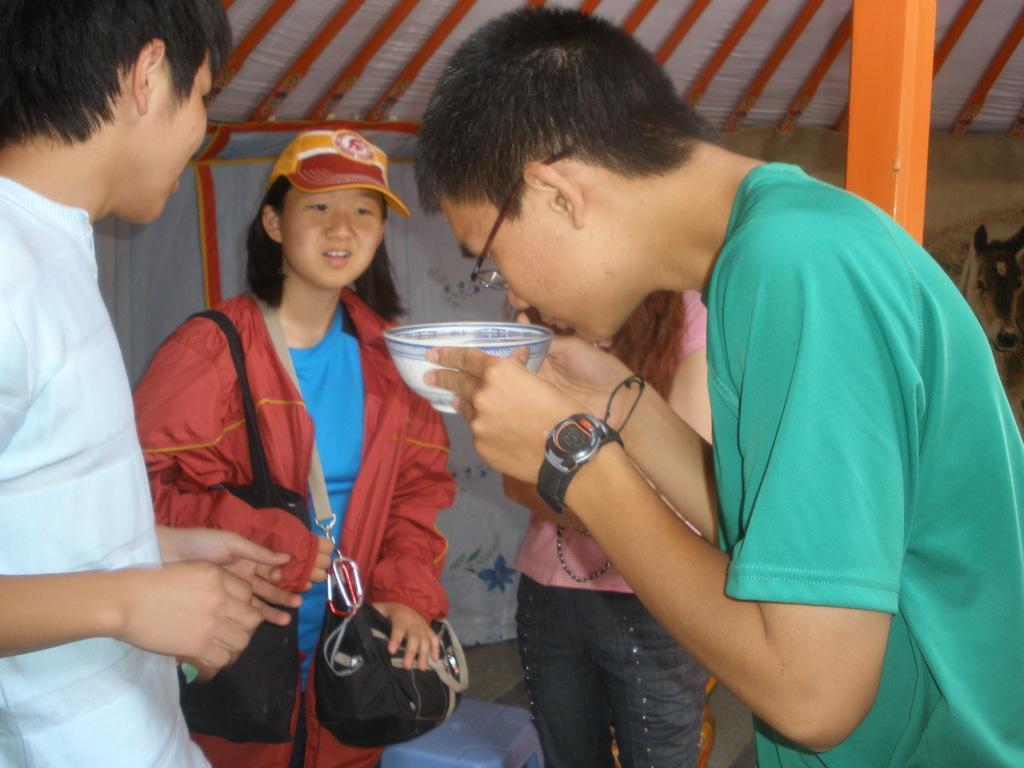How would you summarize this image in a sentence or two? In this image, we can see a person holding a bowl. Beside him, we can see three persons standing. In the middle of the image, we can see a woman wearing bags and a cap. On the right side of the image, there is a pole. In the background, we can see a tent. 